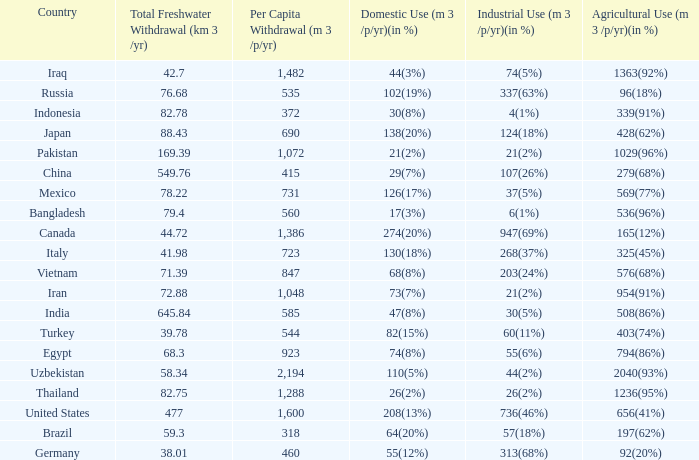What is the highest Per Capita Withdrawal (m 3 /p/yr), when Agricultural Use (m 3 /p/yr)(in %) is 1363(92%), and when Total Freshwater Withdrawal (km 3 /yr) is less than 42.7? None. 